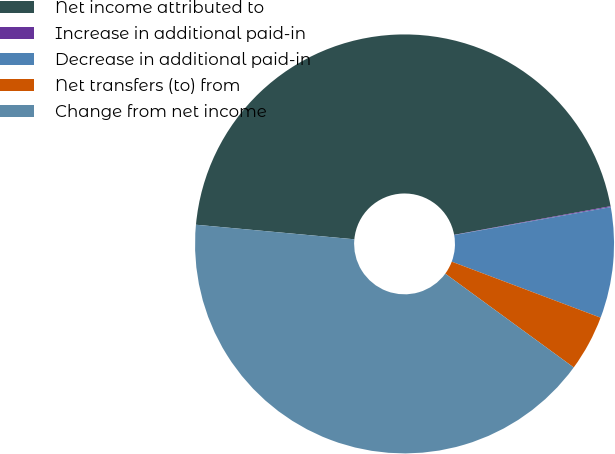Convert chart. <chart><loc_0><loc_0><loc_500><loc_500><pie_chart><fcel>Net income attributed to<fcel>Increase in additional paid-in<fcel>Decrease in additional paid-in<fcel>Net transfers (to) from<fcel>Change from net income<nl><fcel>45.66%<fcel>0.07%<fcel>8.54%<fcel>4.31%<fcel>41.42%<nl></chart> 